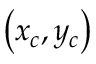Convert formula to latex. <formula><loc_0><loc_0><loc_500><loc_500>\left ( x _ { c } , y _ { c } \right )</formula> 